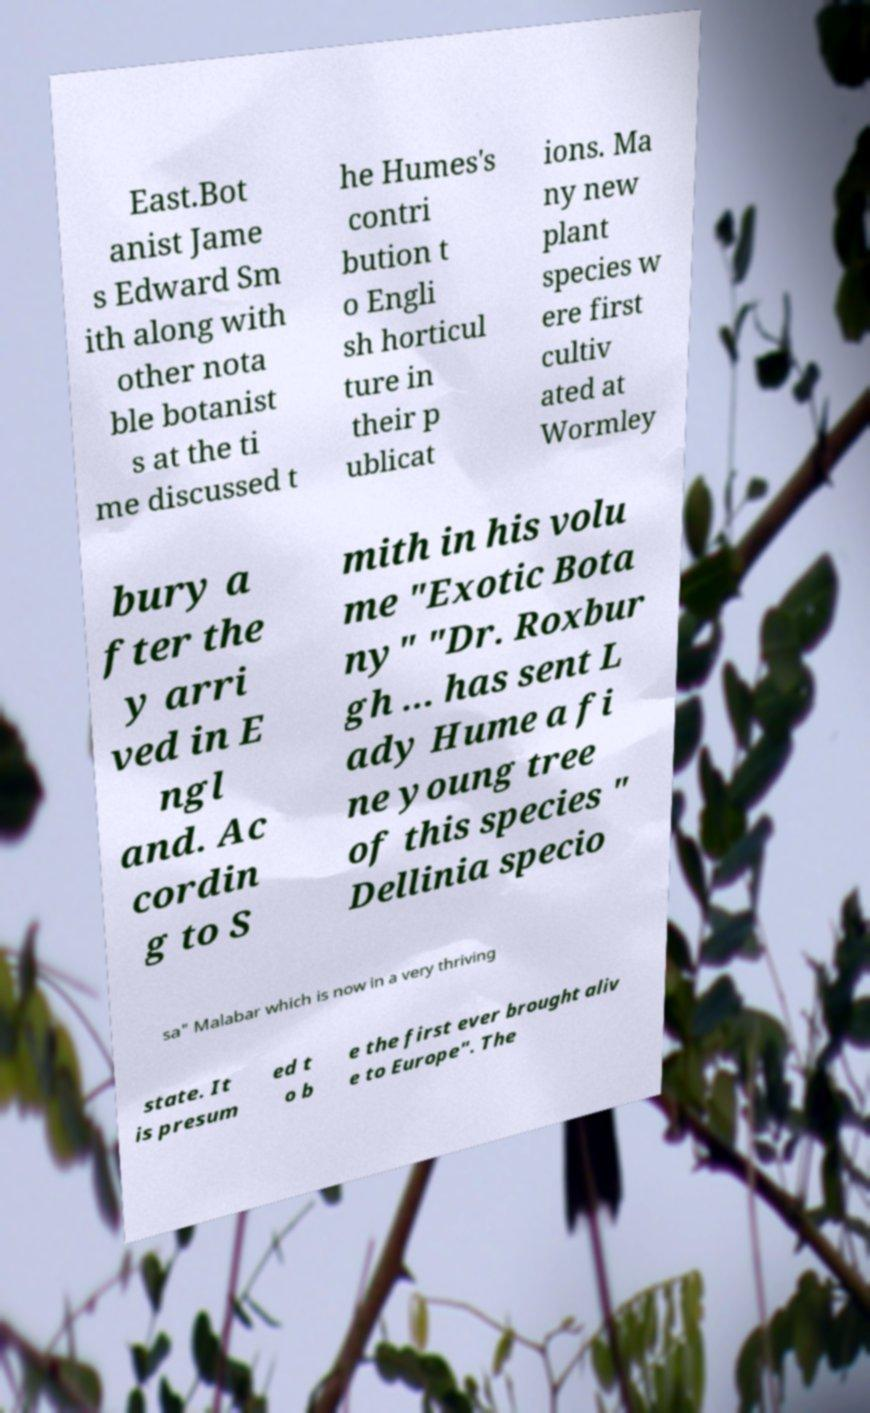Could you extract and type out the text from this image? East.Bot anist Jame s Edward Sm ith along with other nota ble botanist s at the ti me discussed t he Humes's contri bution t o Engli sh horticul ture in their p ublicat ions. Ma ny new plant species w ere first cultiv ated at Wormley bury a fter the y arri ved in E ngl and. Ac cordin g to S mith in his volu me "Exotic Bota ny" "Dr. Roxbur gh ... has sent L ady Hume a fi ne young tree of this species " Dellinia specio sa" Malabar which is now in a very thriving state. It is presum ed t o b e the first ever brought aliv e to Europe". The 